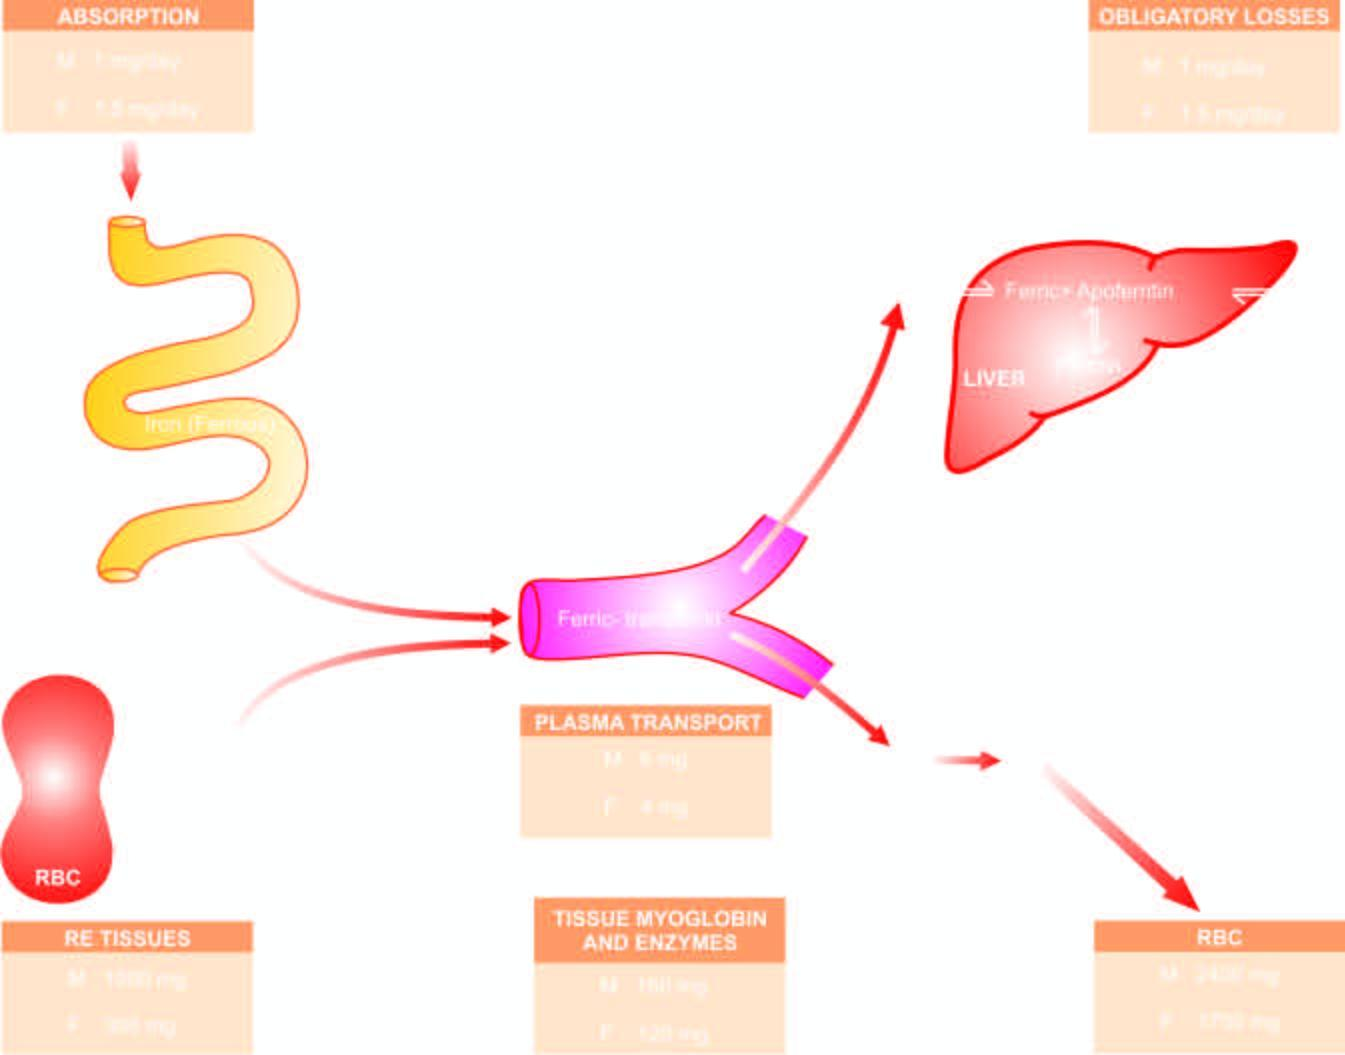what is stored as ferritin and haemosiderin?
Answer the question using a single word or phrase. Iron 